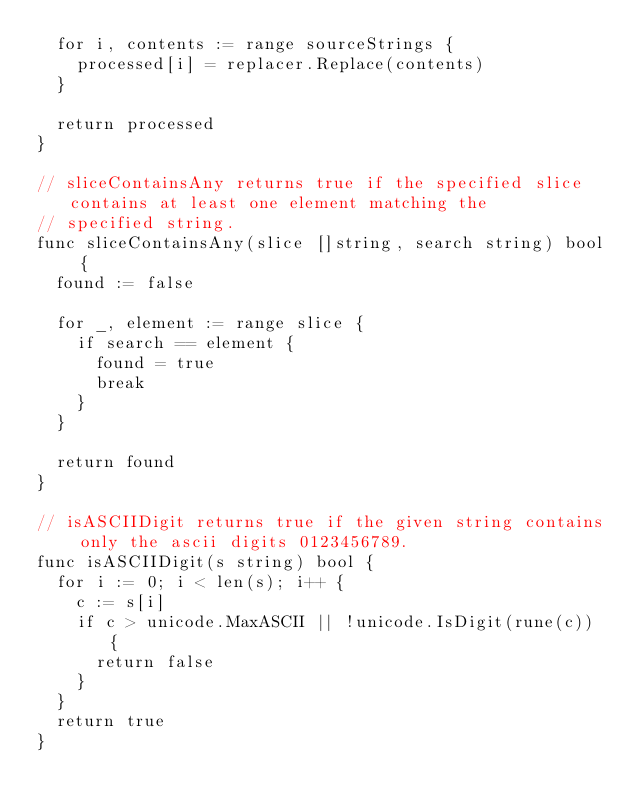<code> <loc_0><loc_0><loc_500><loc_500><_Go_>	for i, contents := range sourceStrings {
		processed[i] = replacer.Replace(contents)
	}

	return processed
}

// sliceContainsAny returns true if the specified slice contains at least one element matching the
// specified string.
func sliceContainsAny(slice []string, search string) bool {
	found := false

	for _, element := range slice {
		if search == element {
			found = true
			break
		}
	}

	return found
}

// isASCIIDigit returns true if the given string contains only the ascii digits 0123456789.
func isASCIIDigit(s string) bool {
	for i := 0; i < len(s); i++ {
		c := s[i]
		if c > unicode.MaxASCII || !unicode.IsDigit(rune(c)) {
			return false
		}
	}
	return true
}
</code> 